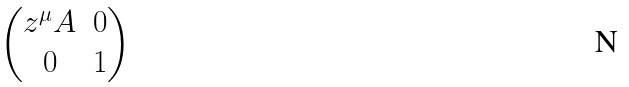<formula> <loc_0><loc_0><loc_500><loc_500>\begin{pmatrix} z ^ { \mu } A & 0 \\ 0 & 1 \end{pmatrix}</formula> 